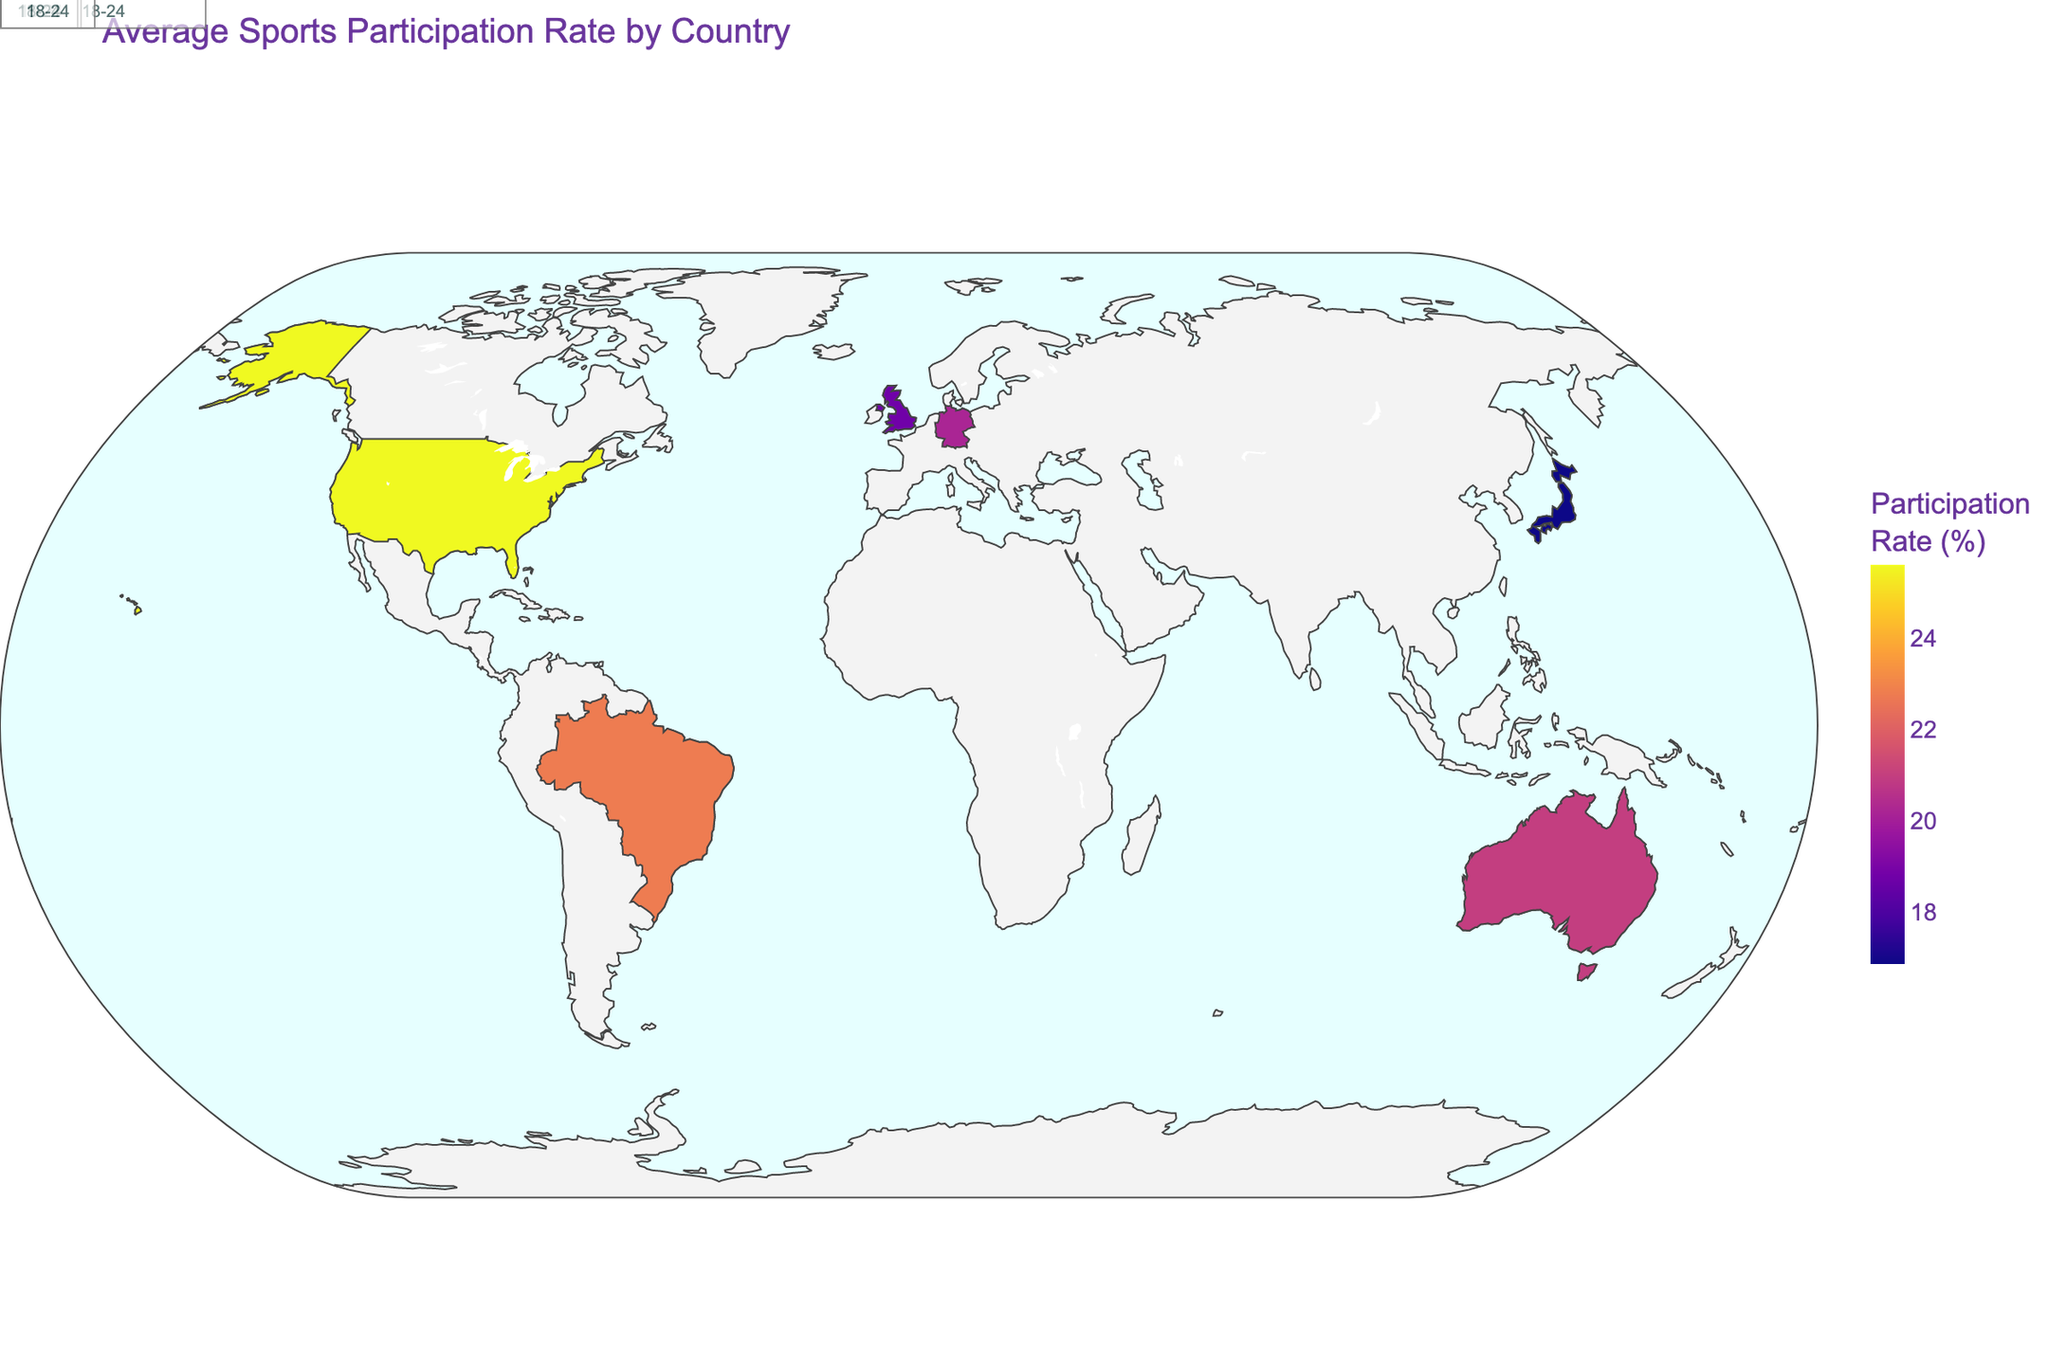How is the title described in the figure? The title of the figure is shown at the top and describes the content accurately by mentioning 'Average Sports Participation Rate by Country'.
Answer: Average Sports Participation Rate by Country Which country has the highest average sports participation rate? By looking at the color intensity on the map, Brazil has the darkest color, indicating it has the highest average sports participation rate.
Answer: Brazil Which country has the lowest average sports participation rate? By identifying the country with the lightest color on the map, the United Kingdom has the lightest shade, indicating the lowest average sports participation rate.
Answer: United Kingdom What is the average participation rate for the United States? The map includes the United States, and its color shade indicates the average participation rate. Hovering over the United States will show the exact percentage.
Answer: 25.6% Which sport and age group have the highest participation rate in Germany? Referring to the annotations on the map, Germany is marked with Football and the age group 18-24, indicating it as the sport with the highest participation rate within the country.
Answer: Football, 18-24 Compare the average participation rates between Australia and Japan. Which one is higher and by how much? Examine the color shade of both countries on the map and hover over each to see their respective average participation rates. Subtract Japan's rate from Australia's rate to determine the difference.
Answer: Australia has a higher rate by 3.2% How does the sports participation rate of 18-24 year-olds in Brazil compare to that of the 25-34 year-olds in the United Kingdom? Referring to the given data, the participation rate for 18-24 year-olds in Brazil is 35.7%, and for 25-34 year-olds in the United Kingdom, it is 15.6%. Subtract the latter from the former to see the comparison.
Answer: Brazil's rate is 20.1% higher Which age group has the lowest participation rate in Japan, and what is that rate? By looking at the provided data, the 45-54 age group is identified as having the lowest participation rate in Japan with 9.7%.
Answer: 45-54, 9.7% What sport and age group annotation is added for Australia on the map? By locating the annotation for Australia in the map, it includes Cricket for the 25-34 age group.
Answer: Cricket, 25-34 Are the colors on the map associated with higher or lower levels of sports participation? Checking the legend on the map, darker shades are associated with higher levels of sports participation, while lighter shades indicate lower levels.
Answer: Darker colors = higher, Lighter colors = lower 